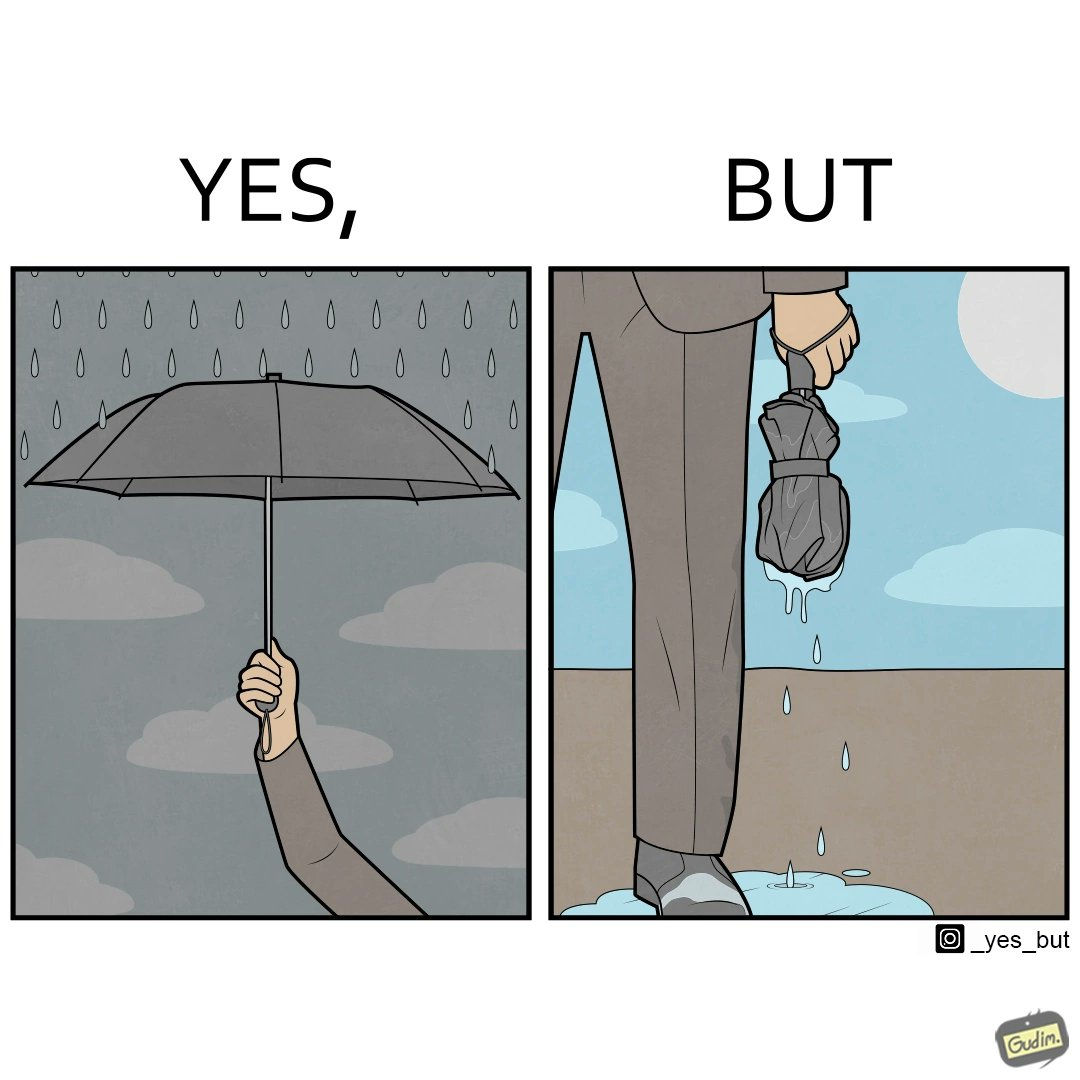Describe the satirical element in this image. The image is funny because while the umbrella helps a person avoid getting wet from rain, when the rain stops and the umbrella is folded, the wet umbrella iteself drips water on the person holding it. 